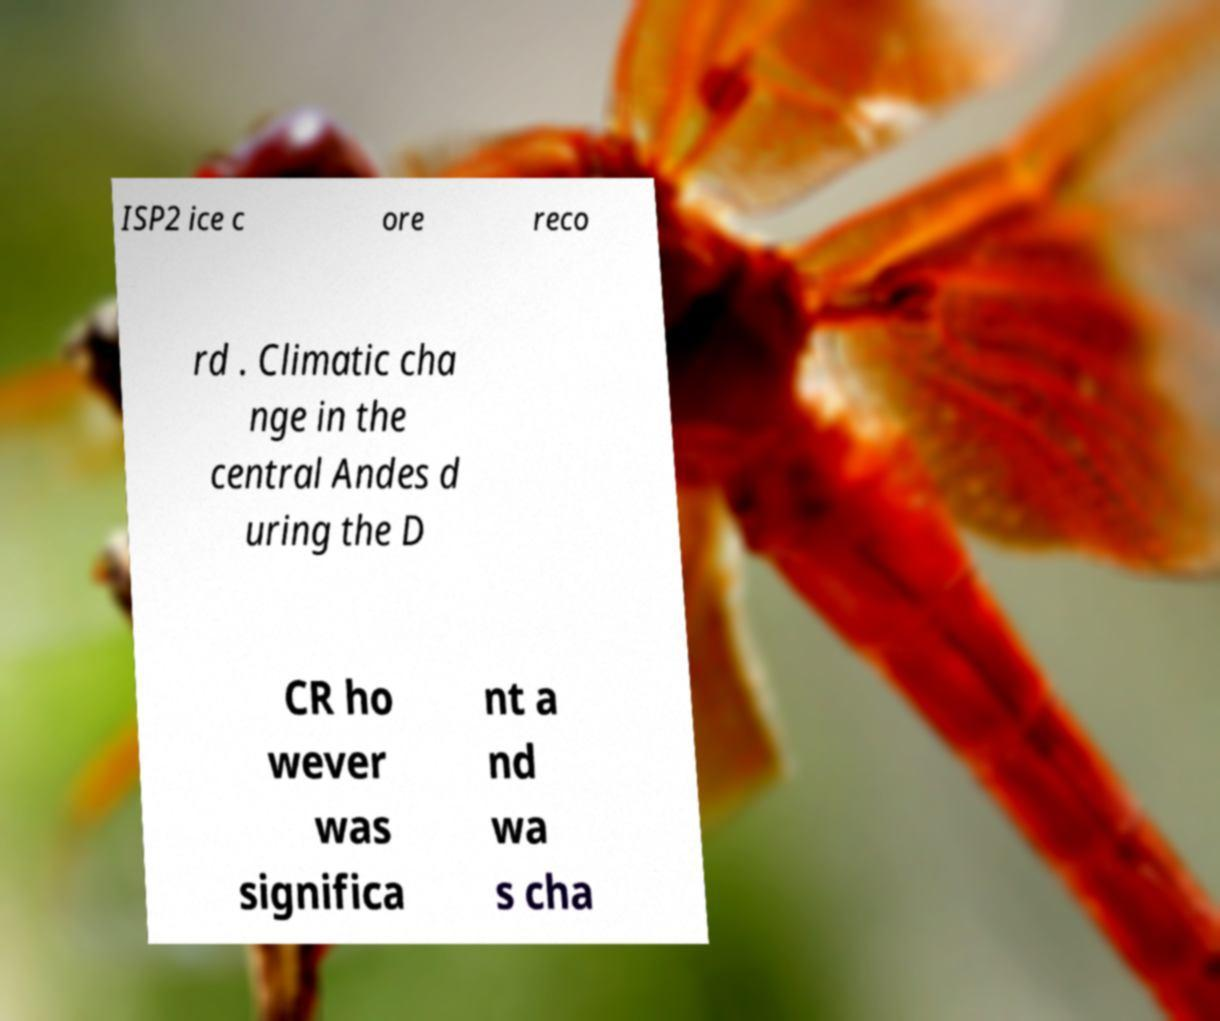Please read and relay the text visible in this image. What does it say? ISP2 ice c ore reco rd . Climatic cha nge in the central Andes d uring the D CR ho wever was significa nt a nd wa s cha 